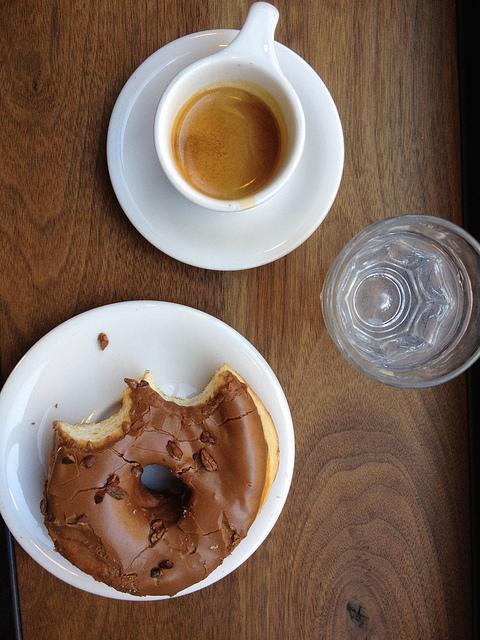What flavor is the frosting on the donut?
Give a very brief answer. Chocolate. Where is the donut?
Give a very brief answer. On plate. What has been eaten?
Quick response, please. Doughnut. How does the barista create these leaf patterns?
Answer briefly. Cream. 